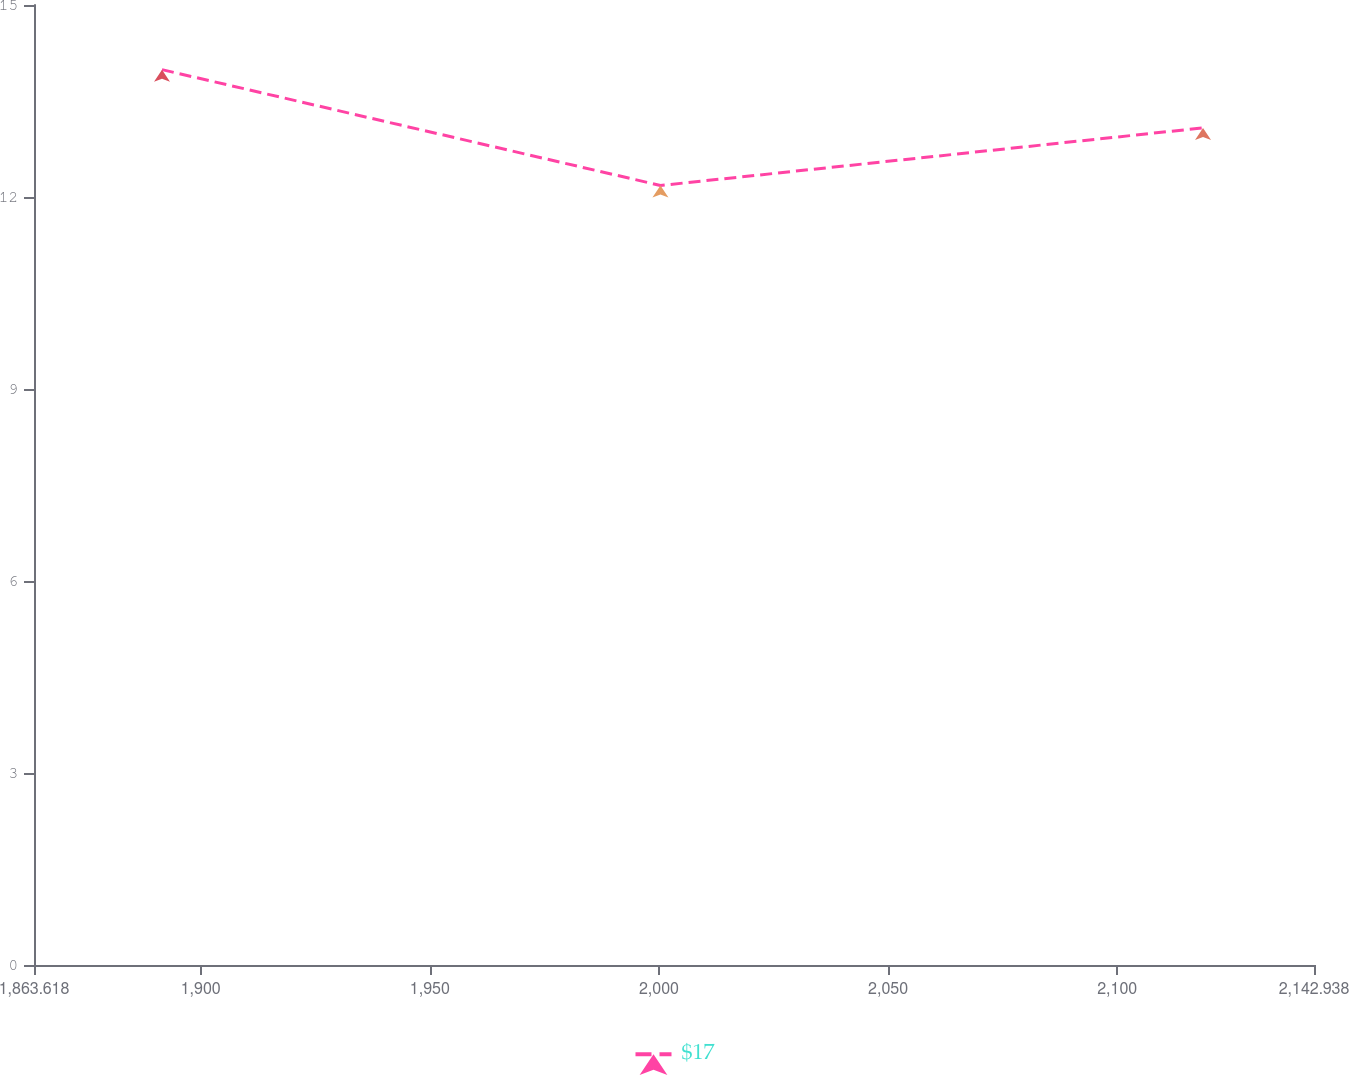Convert chart. <chart><loc_0><loc_0><loc_500><loc_500><line_chart><ecel><fcel>$17<nl><fcel>1891.55<fcel>13.99<nl><fcel>2000.32<fcel>12.18<nl><fcel>2118.72<fcel>13.08<nl><fcel>2170.87<fcel>8.34<nl></chart> 